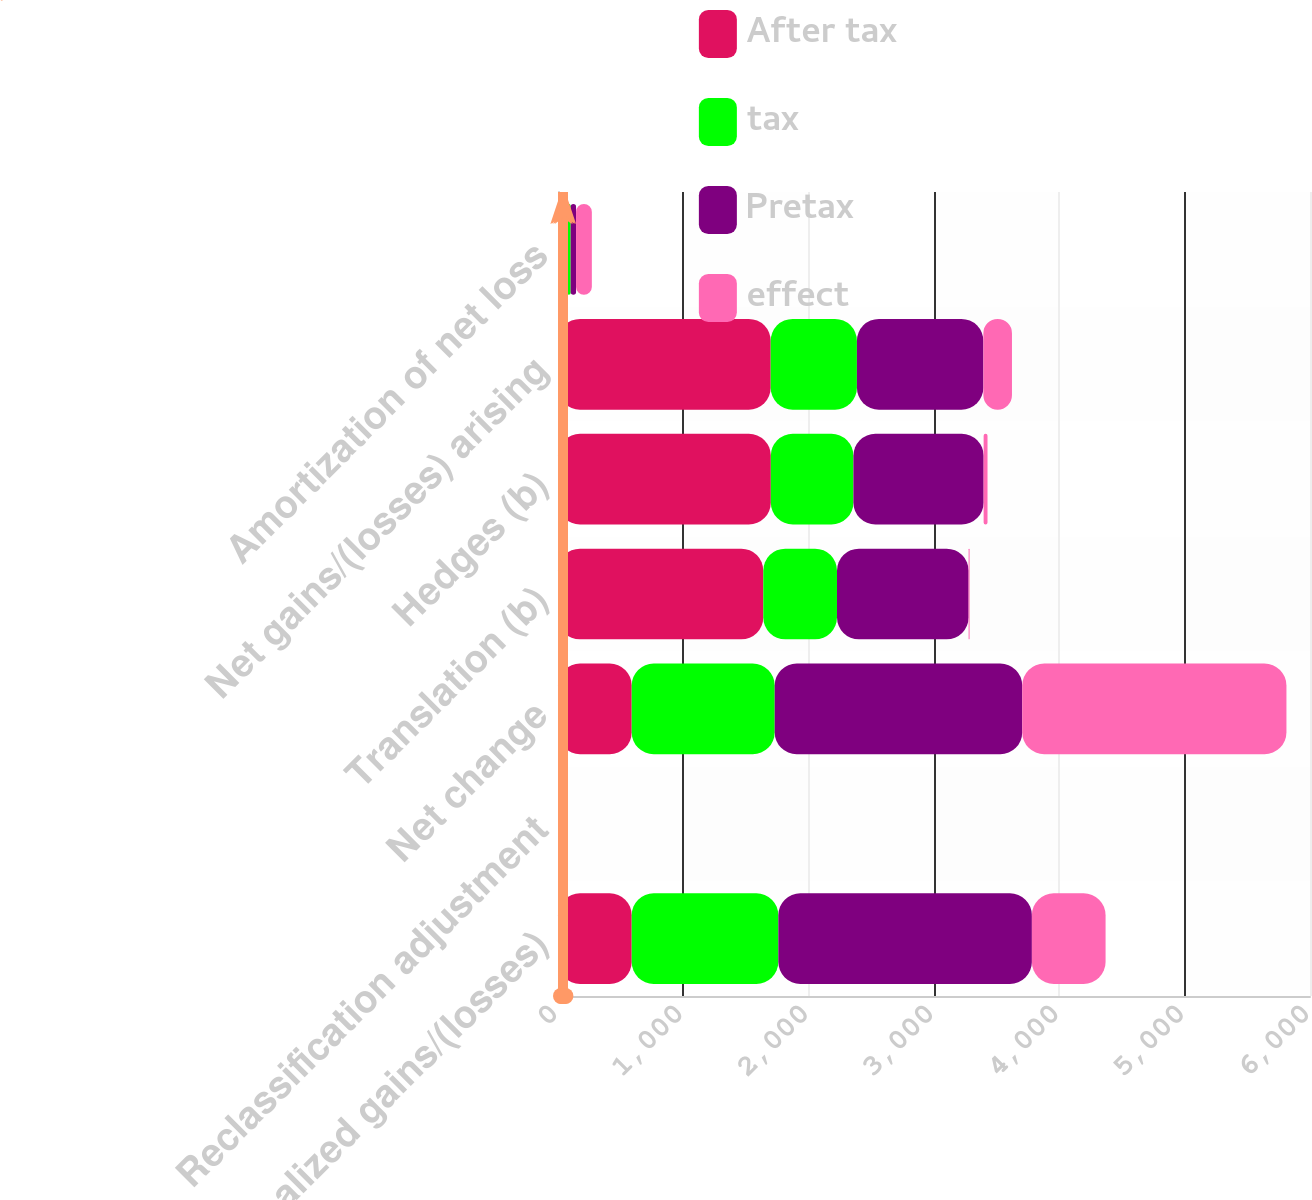Convert chart to OTSL. <chart><loc_0><loc_0><loc_500><loc_500><stacked_bar_chart><ecel><fcel>Net unrealized gains/(losses)<fcel>Reclassification adjustment<fcel>Net change<fcel>Translation (b)<fcel>Hedges (b)<fcel>Net gains/(losses) arising<fcel>Amortization of net loss<nl><fcel>After tax<fcel>588<fcel>24<fcel>588<fcel>1638<fcel>1698<fcel>1697<fcel>72<nl><fcel>tax<fcel>1170<fcel>9<fcel>1141<fcel>588<fcel>659<fcel>688<fcel>29<nl><fcel>Pretax<fcel>2023<fcel>15<fcel>1975<fcel>1050<fcel>1039<fcel>1009<fcel>43<nl><fcel>effect<fcel>588<fcel>11<fcel>2108<fcel>8<fcel>31<fcel>228<fcel>126<nl></chart> 